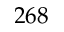Convert formula to latex. <formula><loc_0><loc_0><loc_500><loc_500>2 6 8</formula> 